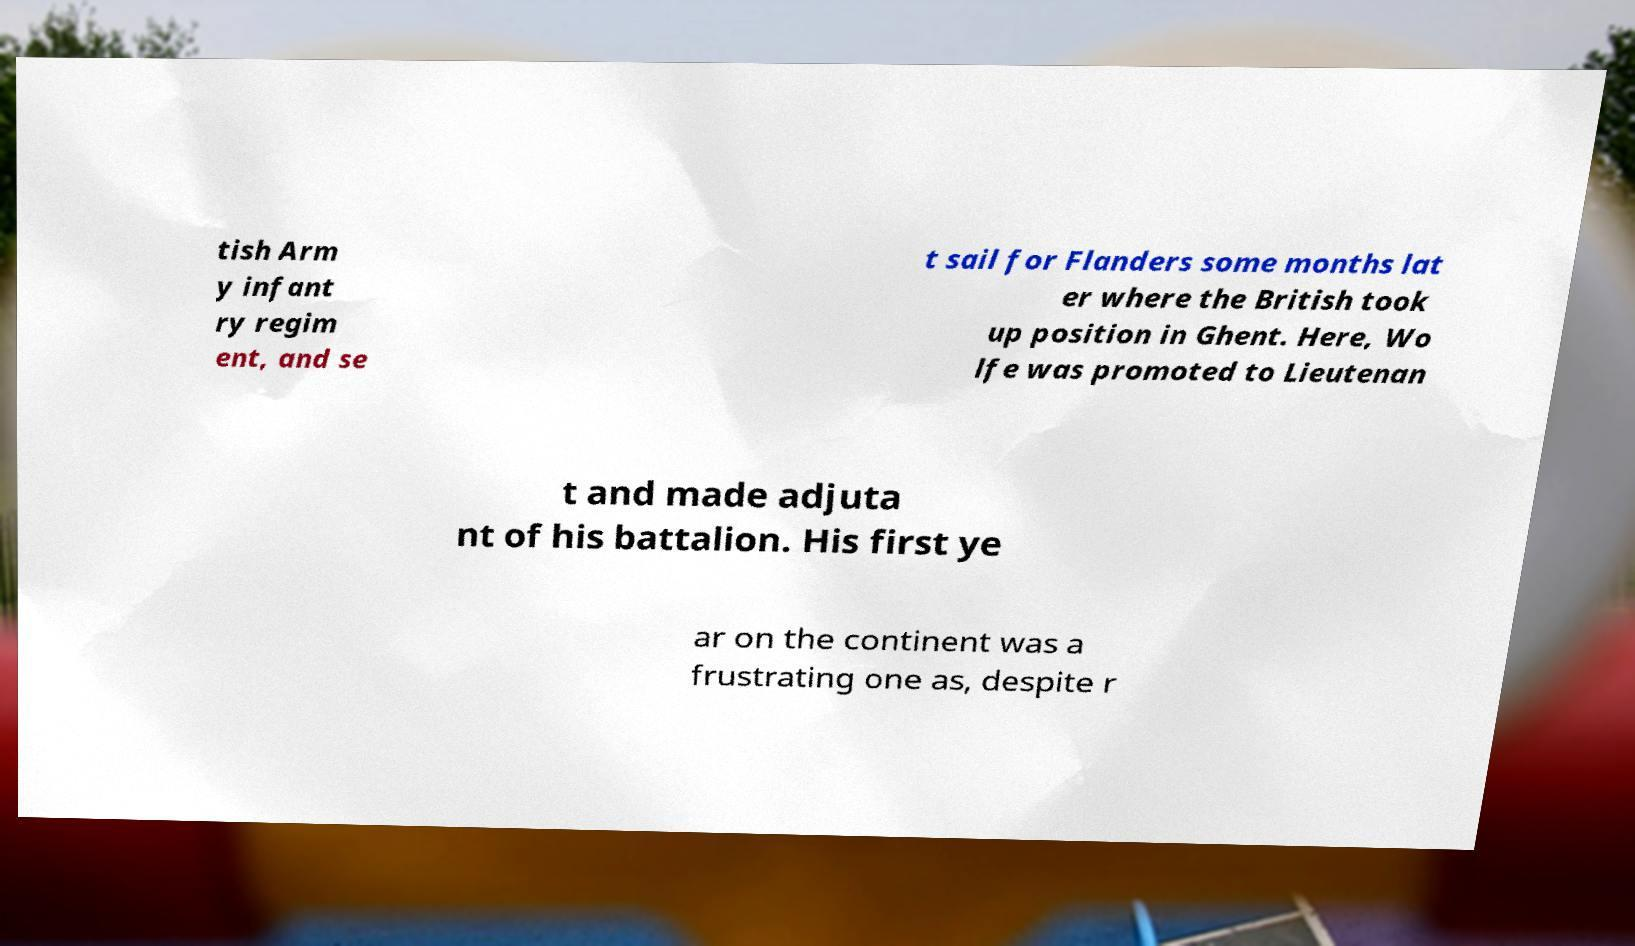I need the written content from this picture converted into text. Can you do that? tish Arm y infant ry regim ent, and se t sail for Flanders some months lat er where the British took up position in Ghent. Here, Wo lfe was promoted to Lieutenan t and made adjuta nt of his battalion. His first ye ar on the continent was a frustrating one as, despite r 